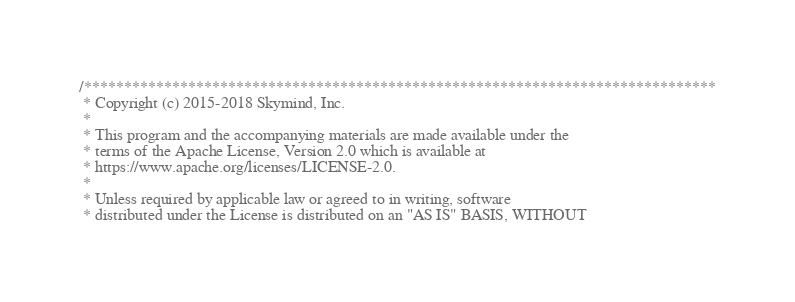Convert code to text. <code><loc_0><loc_0><loc_500><loc_500><_Cuda_>/*******************************************************************************
 * Copyright (c) 2015-2018 Skymind, Inc.
 *
 * This program and the accompanying materials are made available under the
 * terms of the Apache License, Version 2.0 which is available at
 * https://www.apache.org/licenses/LICENSE-2.0.
 *
 * Unless required by applicable law or agreed to in writing, software
 * distributed under the License is distributed on an "AS IS" BASIS, WITHOUT</code> 